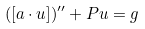<formula> <loc_0><loc_0><loc_500><loc_500>( [ a \cdot u ] ) ^ { \prime \prime } + P u = g</formula> 